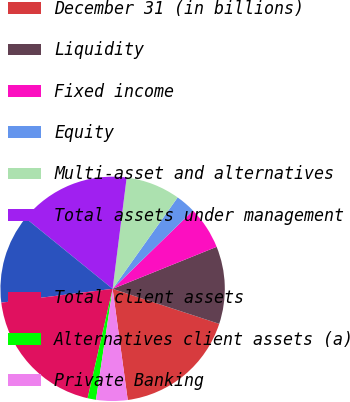<chart> <loc_0><loc_0><loc_500><loc_500><pie_chart><fcel>December 31 (in billions)<fcel>Liquidity<fcel>Fixed income<fcel>Equity<fcel>Multi-asset and alternatives<fcel>Total assets under management<fcel>Unnamed: 6<fcel>Total client assets<fcel>Alternatives client assets (a)<fcel>Private Banking<nl><fcel>17.8%<fcel>11.16%<fcel>6.18%<fcel>2.87%<fcel>7.84%<fcel>16.14%<fcel>12.82%<fcel>19.46%<fcel>1.21%<fcel>4.52%<nl></chart> 